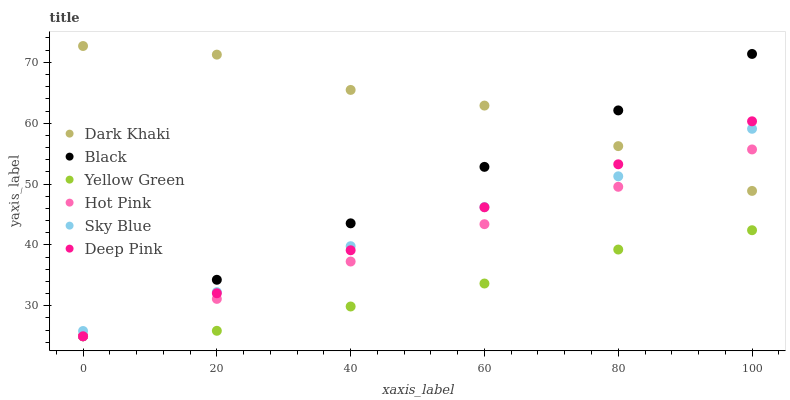Does Yellow Green have the minimum area under the curve?
Answer yes or no. Yes. Does Dark Khaki have the maximum area under the curve?
Answer yes or no. Yes. Does Hot Pink have the minimum area under the curve?
Answer yes or no. No. Does Hot Pink have the maximum area under the curve?
Answer yes or no. No. Is Hot Pink the smoothest?
Answer yes or no. Yes. Is Dark Khaki the roughest?
Answer yes or no. Yes. Is Yellow Green the smoothest?
Answer yes or no. No. Is Yellow Green the roughest?
Answer yes or no. No. Does Deep Pink have the lowest value?
Answer yes or no. Yes. Does Dark Khaki have the lowest value?
Answer yes or no. No. Does Dark Khaki have the highest value?
Answer yes or no. Yes. Does Hot Pink have the highest value?
Answer yes or no. No. Is Yellow Green less than Dark Khaki?
Answer yes or no. Yes. Is Sky Blue greater than Yellow Green?
Answer yes or no. Yes. Does Hot Pink intersect Dark Khaki?
Answer yes or no. Yes. Is Hot Pink less than Dark Khaki?
Answer yes or no. No. Is Hot Pink greater than Dark Khaki?
Answer yes or no. No. Does Yellow Green intersect Dark Khaki?
Answer yes or no. No. 